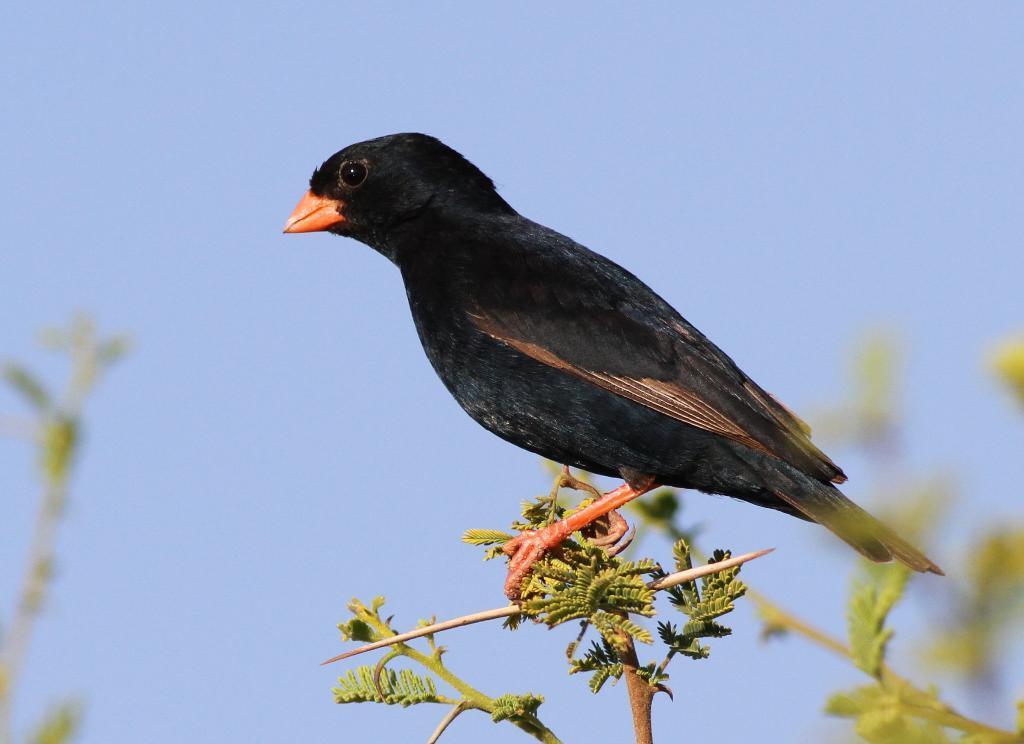How would you summarize this image in a sentence or two? In this image we can see a black bird on a branch of a tree. Behind the bird we can see the sky. 